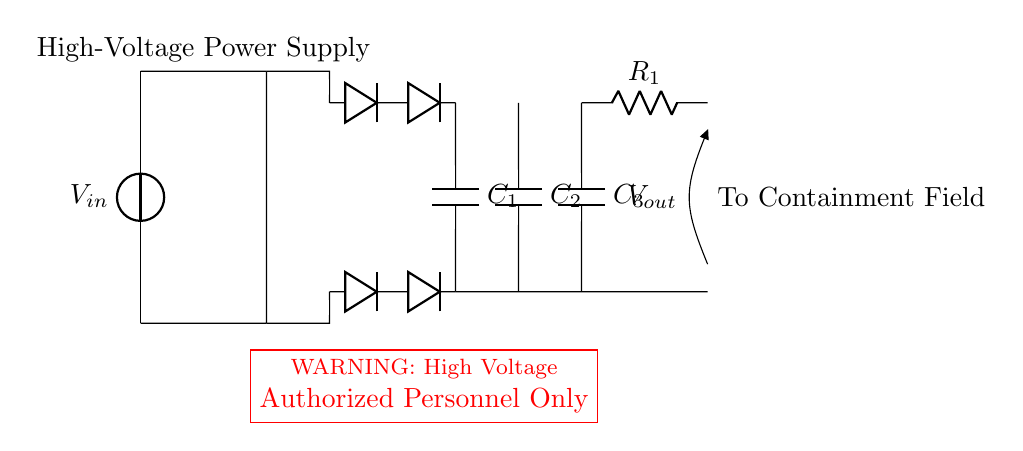What is the type of the voltage source? The voltage source is labeled as a direct current (DC) source indicated by the 'vsource' in the diagram.
Answer: DC What is the purpose of the transformer in this circuit? The transformer steps up or steps down the voltage based on the design, which is critical for high-voltage applications.
Answer: Voltage adjustment How many capacitors are present in the circuit? There are three capacitors, as shown by the labels C1, C2, and C3 in the diagram.
Answer: Three What type of diodes are used in this circuit? The diodes in this circuit are standard rectifier diodes indicated by their typical representation in the schematic.
Answer: Rectifier diodes What safety warning is indicated in the circuit diagram? The safety warning states "WARNING: High Voltage Authorized Personnel Only," emphasizing the danger of the circuit.
Answer: High voltage warning What is the function of the current limiting resistor? The current limiting resistor is included to regulate the output current and prevent damage to the connected load.
Answer: Current regulation 